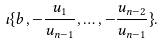<formula> <loc_0><loc_0><loc_500><loc_500>\iota \{ b , - \frac { u _ { 1 } } { u _ { n - 1 } } , \dots , - \frac { u _ { n - 2 } } { u _ { n - 1 } } \} .</formula> 